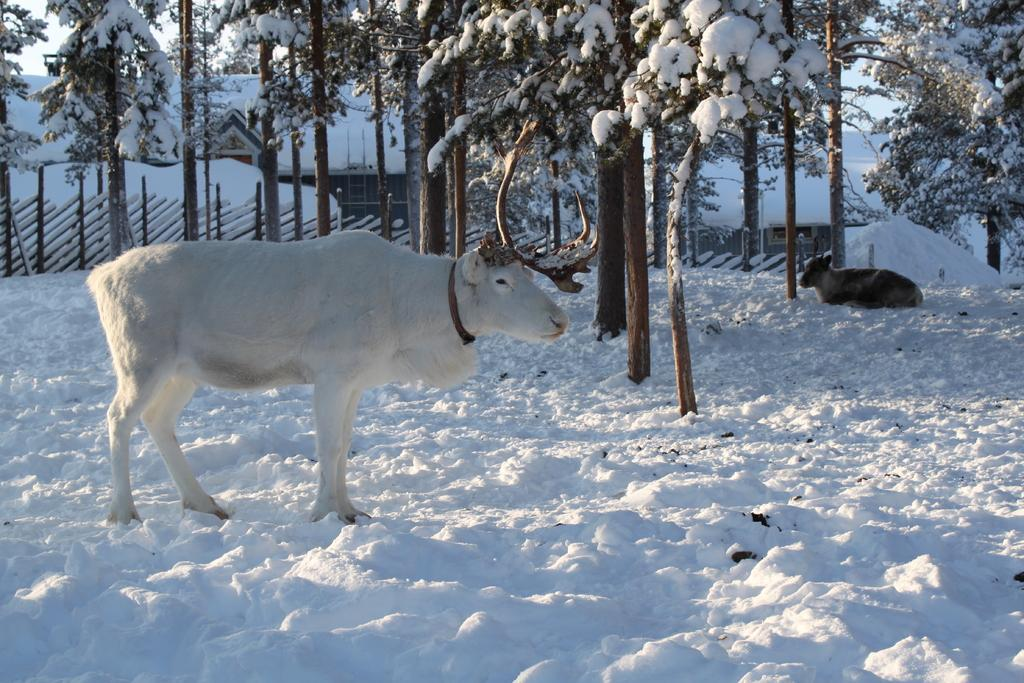How many animals can be seen in the image? There are two animals in the image. What is the setting in which the animals are located? The animals are on the snow. What other features can be observed in the image? There are trees covered with snow and houses in the image. What is visible in the background of the image? The sky is visible in the background of the image. What type of kitty is playing the guitar on the cloth in the image? There is no kitty, guitar, or cloth present in the image. 